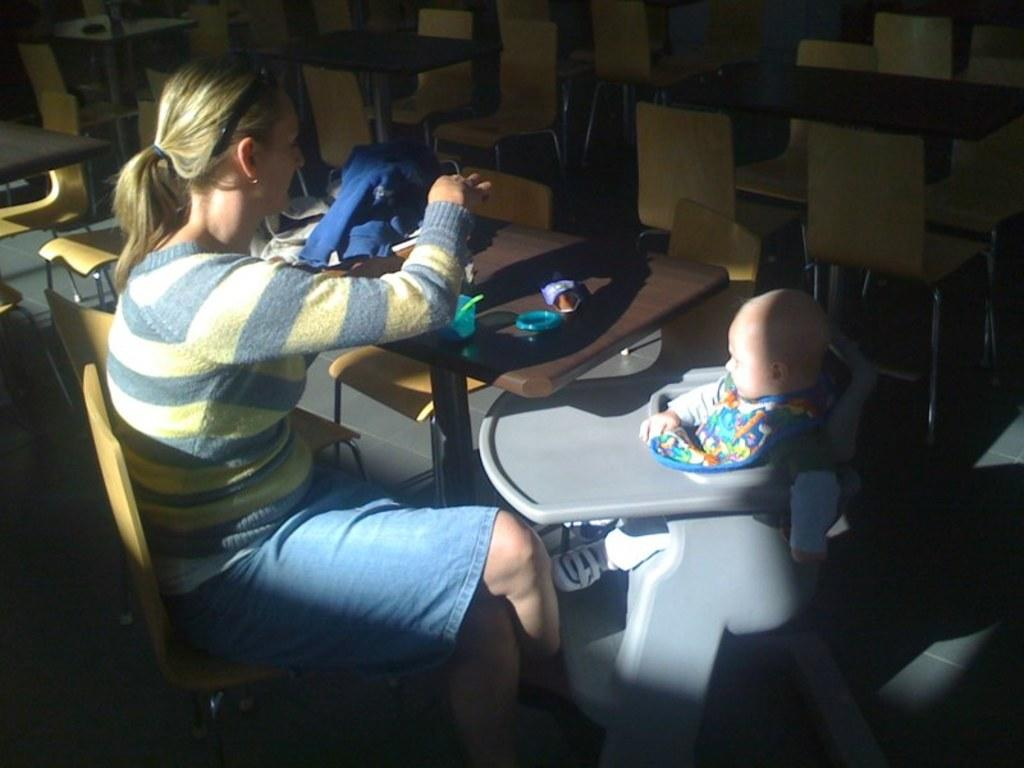What is the woman doing in the image? The woman is sitting on a chair in the image. Who else is present in the image? There is a child in the image. What piece of furniture is visible in the image? There is a table in the image. What object is placed on the table? A jacket is placed on the table. What color is the jacket? The jacket is blue in color. What type of flesh can be seen on the child's face in the image? There is no flesh visible on the child's face in the image; it is a photograph and not a physical representation. 